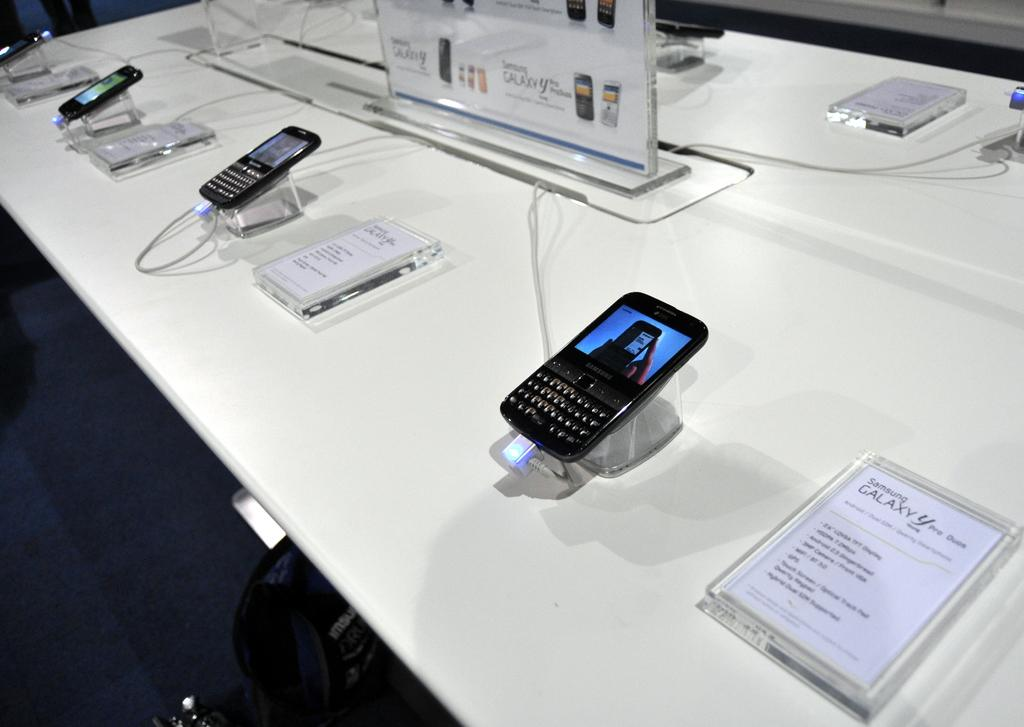<image>
Offer a succinct explanation of the picture presented. a phone that has the Samsung brand on it 